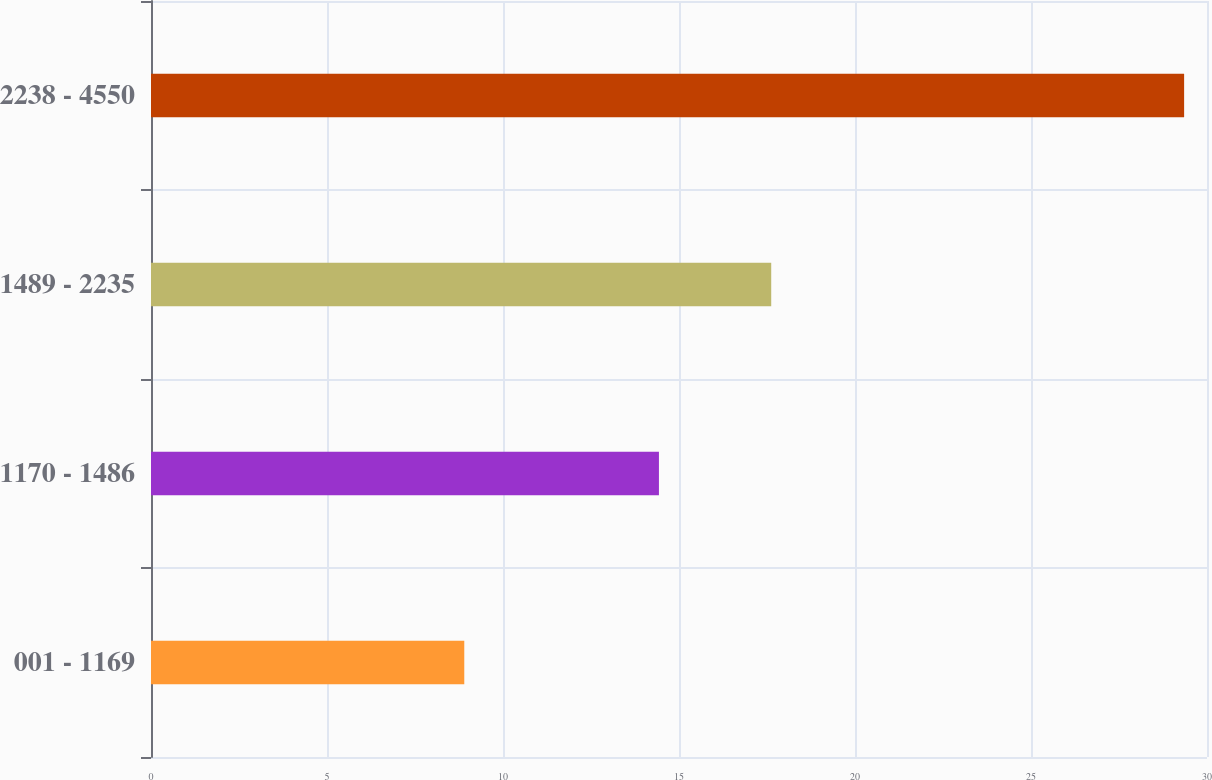Convert chart to OTSL. <chart><loc_0><loc_0><loc_500><loc_500><bar_chart><fcel>001 - 1169<fcel>1170 - 1486<fcel>1489 - 2235<fcel>2238 - 4550<nl><fcel>8.9<fcel>14.43<fcel>17.62<fcel>29.35<nl></chart> 